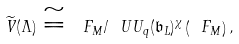<formula> <loc_0><loc_0><loc_500><loc_500>\widetilde { V } ( \Lambda ) \cong \ F _ { M } / \ U U _ { q } ( { \mathfrak b } _ { L } ) ^ { \chi } \left ( \ F _ { M } \right ) ,</formula> 